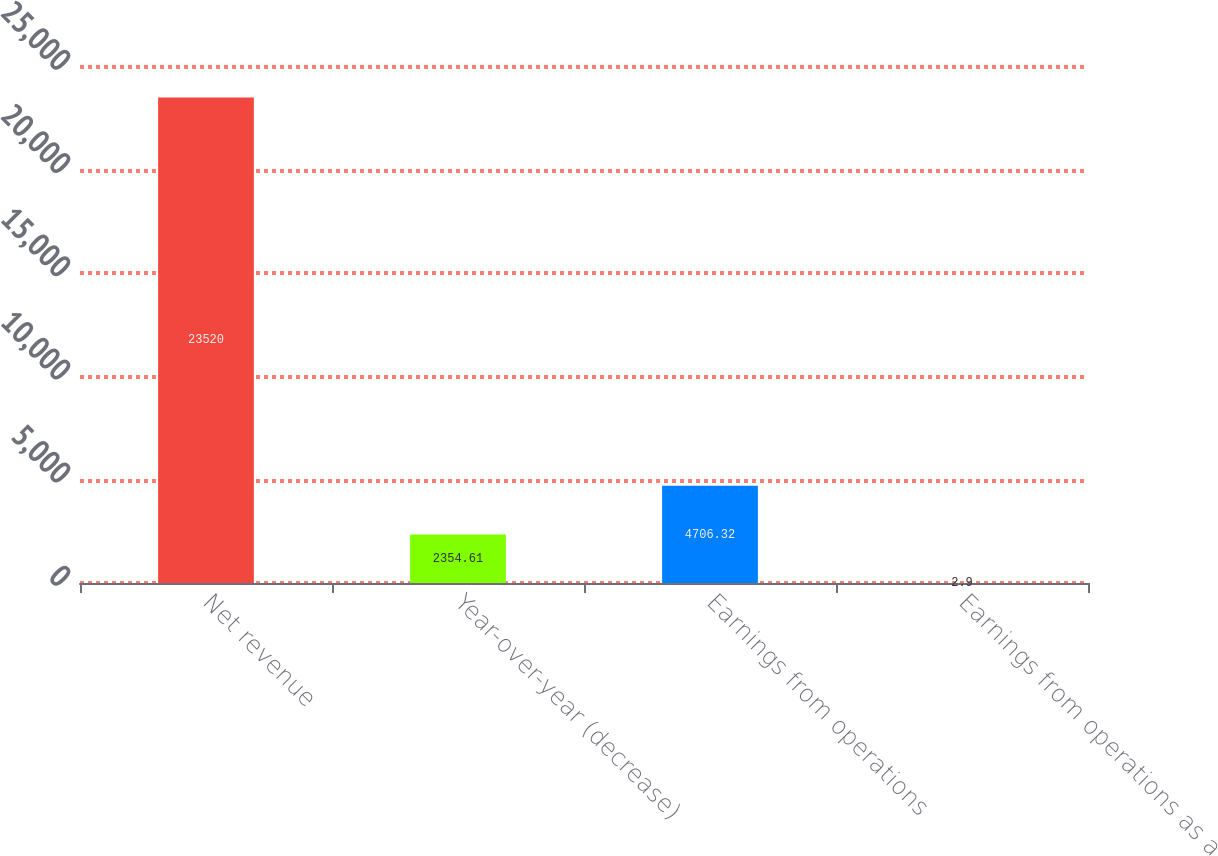Convert chart. <chart><loc_0><loc_0><loc_500><loc_500><bar_chart><fcel>Net revenue<fcel>Year-over-year (decrease)<fcel>Earnings from operations<fcel>Earnings from operations as a<nl><fcel>23520<fcel>2354.61<fcel>4706.32<fcel>2.9<nl></chart> 